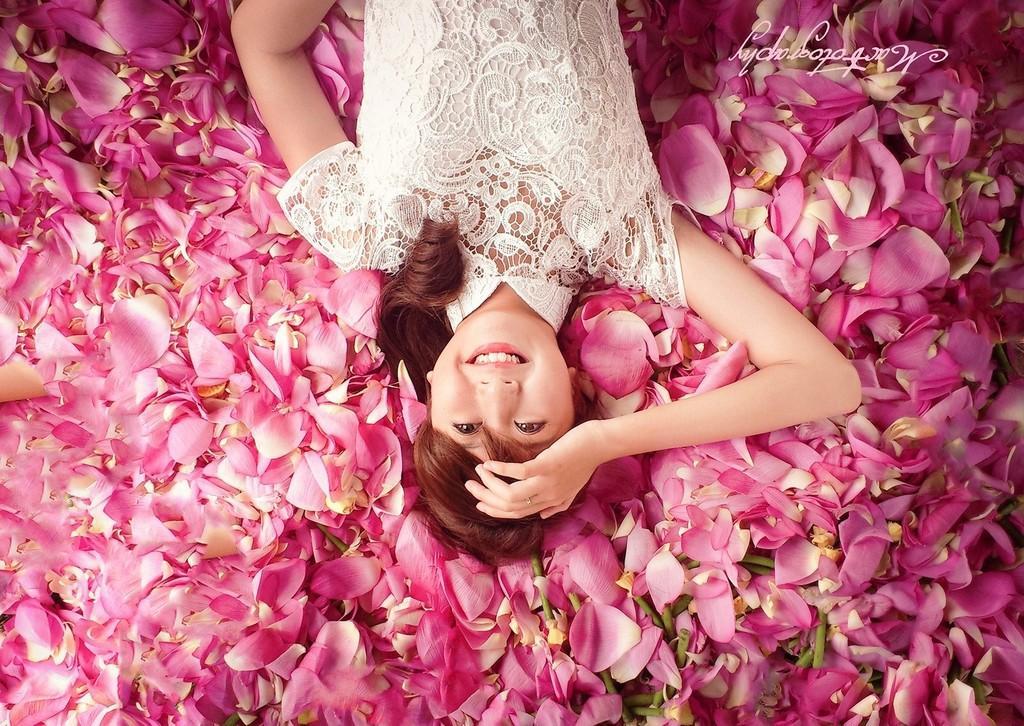Can you describe this image briefly? In this picture there is a woman with white dress is laying on the rose petals and smiling. At the bottom there are rose petals. At the top right there is a text. 